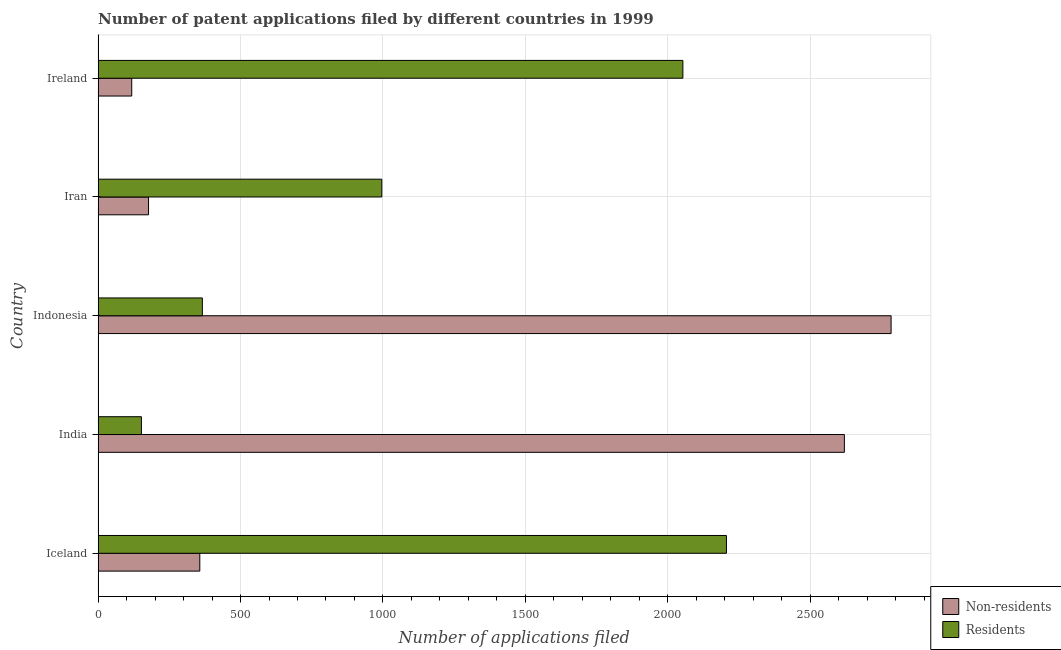How many different coloured bars are there?
Give a very brief answer. 2. Are the number of bars per tick equal to the number of legend labels?
Provide a short and direct response. Yes. Are the number of bars on each tick of the Y-axis equal?
Provide a succinct answer. Yes. How many bars are there on the 1st tick from the top?
Provide a succinct answer. 2. How many bars are there on the 2nd tick from the bottom?
Provide a short and direct response. 2. What is the number of patent applications by non residents in Indonesia?
Provide a short and direct response. 2784. Across all countries, what is the maximum number of patent applications by non residents?
Provide a short and direct response. 2784. Across all countries, what is the minimum number of patent applications by residents?
Your response must be concise. 152. In which country was the number of patent applications by non residents minimum?
Your answer should be compact. Ireland. What is the total number of patent applications by non residents in the graph?
Provide a short and direct response. 6056. What is the difference between the number of patent applications by residents in India and that in Iran?
Provide a succinct answer. -844. What is the difference between the number of patent applications by non residents in Iran and the number of patent applications by residents in India?
Your answer should be compact. 25. What is the average number of patent applications by residents per country?
Offer a very short reply. 1154.6. What is the difference between the number of patent applications by residents and number of patent applications by non residents in Indonesia?
Make the answer very short. -2418. In how many countries, is the number of patent applications by residents greater than 2700 ?
Offer a terse response. 0. What is the ratio of the number of patent applications by residents in Iceland to that in India?
Give a very brief answer. 14.51. Is the difference between the number of patent applications by non residents in India and Indonesia greater than the difference between the number of patent applications by residents in India and Indonesia?
Provide a short and direct response. Yes. What is the difference between the highest and the second highest number of patent applications by non residents?
Your answer should be very brief. 164. What is the difference between the highest and the lowest number of patent applications by non residents?
Provide a succinct answer. 2666. In how many countries, is the number of patent applications by non residents greater than the average number of patent applications by non residents taken over all countries?
Keep it short and to the point. 2. Is the sum of the number of patent applications by residents in Indonesia and Ireland greater than the maximum number of patent applications by non residents across all countries?
Your answer should be compact. No. What does the 2nd bar from the top in India represents?
Your answer should be very brief. Non-residents. What does the 2nd bar from the bottom in Iran represents?
Give a very brief answer. Residents. How many bars are there?
Provide a succinct answer. 10. Are all the bars in the graph horizontal?
Give a very brief answer. Yes. Are the values on the major ticks of X-axis written in scientific E-notation?
Keep it short and to the point. No. Does the graph contain any zero values?
Make the answer very short. No. Where does the legend appear in the graph?
Offer a terse response. Bottom right. How many legend labels are there?
Give a very brief answer. 2. How are the legend labels stacked?
Provide a short and direct response. Vertical. What is the title of the graph?
Give a very brief answer. Number of patent applications filed by different countries in 1999. Does "Commercial service exports" appear as one of the legend labels in the graph?
Offer a terse response. No. What is the label or title of the X-axis?
Your response must be concise. Number of applications filed. What is the label or title of the Y-axis?
Ensure brevity in your answer.  Country. What is the Number of applications filed of Non-residents in Iceland?
Your answer should be very brief. 357. What is the Number of applications filed of Residents in Iceland?
Ensure brevity in your answer.  2206. What is the Number of applications filed in Non-residents in India?
Offer a very short reply. 2620. What is the Number of applications filed in Residents in India?
Give a very brief answer. 152. What is the Number of applications filed of Non-residents in Indonesia?
Ensure brevity in your answer.  2784. What is the Number of applications filed of Residents in Indonesia?
Provide a succinct answer. 366. What is the Number of applications filed of Non-residents in Iran?
Make the answer very short. 177. What is the Number of applications filed of Residents in Iran?
Your response must be concise. 996. What is the Number of applications filed in Non-residents in Ireland?
Your answer should be very brief. 118. What is the Number of applications filed of Residents in Ireland?
Your response must be concise. 2053. Across all countries, what is the maximum Number of applications filed in Non-residents?
Ensure brevity in your answer.  2784. Across all countries, what is the maximum Number of applications filed in Residents?
Provide a succinct answer. 2206. Across all countries, what is the minimum Number of applications filed in Non-residents?
Your answer should be compact. 118. Across all countries, what is the minimum Number of applications filed in Residents?
Provide a short and direct response. 152. What is the total Number of applications filed in Non-residents in the graph?
Offer a terse response. 6056. What is the total Number of applications filed in Residents in the graph?
Provide a succinct answer. 5773. What is the difference between the Number of applications filed in Non-residents in Iceland and that in India?
Give a very brief answer. -2263. What is the difference between the Number of applications filed of Residents in Iceland and that in India?
Offer a very short reply. 2054. What is the difference between the Number of applications filed in Non-residents in Iceland and that in Indonesia?
Keep it short and to the point. -2427. What is the difference between the Number of applications filed in Residents in Iceland and that in Indonesia?
Offer a very short reply. 1840. What is the difference between the Number of applications filed in Non-residents in Iceland and that in Iran?
Offer a terse response. 180. What is the difference between the Number of applications filed in Residents in Iceland and that in Iran?
Your response must be concise. 1210. What is the difference between the Number of applications filed in Non-residents in Iceland and that in Ireland?
Provide a succinct answer. 239. What is the difference between the Number of applications filed in Residents in Iceland and that in Ireland?
Give a very brief answer. 153. What is the difference between the Number of applications filed in Non-residents in India and that in Indonesia?
Offer a very short reply. -164. What is the difference between the Number of applications filed of Residents in India and that in Indonesia?
Your answer should be compact. -214. What is the difference between the Number of applications filed of Non-residents in India and that in Iran?
Make the answer very short. 2443. What is the difference between the Number of applications filed in Residents in India and that in Iran?
Ensure brevity in your answer.  -844. What is the difference between the Number of applications filed in Non-residents in India and that in Ireland?
Ensure brevity in your answer.  2502. What is the difference between the Number of applications filed of Residents in India and that in Ireland?
Offer a terse response. -1901. What is the difference between the Number of applications filed in Non-residents in Indonesia and that in Iran?
Offer a terse response. 2607. What is the difference between the Number of applications filed in Residents in Indonesia and that in Iran?
Ensure brevity in your answer.  -630. What is the difference between the Number of applications filed in Non-residents in Indonesia and that in Ireland?
Give a very brief answer. 2666. What is the difference between the Number of applications filed of Residents in Indonesia and that in Ireland?
Your answer should be very brief. -1687. What is the difference between the Number of applications filed in Non-residents in Iran and that in Ireland?
Provide a short and direct response. 59. What is the difference between the Number of applications filed in Residents in Iran and that in Ireland?
Offer a very short reply. -1057. What is the difference between the Number of applications filed in Non-residents in Iceland and the Number of applications filed in Residents in India?
Your answer should be very brief. 205. What is the difference between the Number of applications filed of Non-residents in Iceland and the Number of applications filed of Residents in Iran?
Ensure brevity in your answer.  -639. What is the difference between the Number of applications filed in Non-residents in Iceland and the Number of applications filed in Residents in Ireland?
Make the answer very short. -1696. What is the difference between the Number of applications filed in Non-residents in India and the Number of applications filed in Residents in Indonesia?
Provide a succinct answer. 2254. What is the difference between the Number of applications filed of Non-residents in India and the Number of applications filed of Residents in Iran?
Provide a short and direct response. 1624. What is the difference between the Number of applications filed in Non-residents in India and the Number of applications filed in Residents in Ireland?
Provide a succinct answer. 567. What is the difference between the Number of applications filed of Non-residents in Indonesia and the Number of applications filed of Residents in Iran?
Ensure brevity in your answer.  1788. What is the difference between the Number of applications filed of Non-residents in Indonesia and the Number of applications filed of Residents in Ireland?
Your answer should be compact. 731. What is the difference between the Number of applications filed of Non-residents in Iran and the Number of applications filed of Residents in Ireland?
Offer a terse response. -1876. What is the average Number of applications filed of Non-residents per country?
Your answer should be very brief. 1211.2. What is the average Number of applications filed of Residents per country?
Give a very brief answer. 1154.6. What is the difference between the Number of applications filed in Non-residents and Number of applications filed in Residents in Iceland?
Offer a terse response. -1849. What is the difference between the Number of applications filed in Non-residents and Number of applications filed in Residents in India?
Give a very brief answer. 2468. What is the difference between the Number of applications filed in Non-residents and Number of applications filed in Residents in Indonesia?
Offer a terse response. 2418. What is the difference between the Number of applications filed of Non-residents and Number of applications filed of Residents in Iran?
Your response must be concise. -819. What is the difference between the Number of applications filed of Non-residents and Number of applications filed of Residents in Ireland?
Offer a terse response. -1935. What is the ratio of the Number of applications filed of Non-residents in Iceland to that in India?
Provide a succinct answer. 0.14. What is the ratio of the Number of applications filed in Residents in Iceland to that in India?
Give a very brief answer. 14.51. What is the ratio of the Number of applications filed in Non-residents in Iceland to that in Indonesia?
Provide a succinct answer. 0.13. What is the ratio of the Number of applications filed of Residents in Iceland to that in Indonesia?
Ensure brevity in your answer.  6.03. What is the ratio of the Number of applications filed in Non-residents in Iceland to that in Iran?
Your response must be concise. 2.02. What is the ratio of the Number of applications filed of Residents in Iceland to that in Iran?
Your answer should be compact. 2.21. What is the ratio of the Number of applications filed in Non-residents in Iceland to that in Ireland?
Offer a very short reply. 3.03. What is the ratio of the Number of applications filed of Residents in Iceland to that in Ireland?
Make the answer very short. 1.07. What is the ratio of the Number of applications filed of Non-residents in India to that in Indonesia?
Your answer should be compact. 0.94. What is the ratio of the Number of applications filed of Residents in India to that in Indonesia?
Your response must be concise. 0.42. What is the ratio of the Number of applications filed of Non-residents in India to that in Iran?
Offer a very short reply. 14.8. What is the ratio of the Number of applications filed in Residents in India to that in Iran?
Your answer should be compact. 0.15. What is the ratio of the Number of applications filed of Non-residents in India to that in Ireland?
Give a very brief answer. 22.2. What is the ratio of the Number of applications filed of Residents in India to that in Ireland?
Your response must be concise. 0.07. What is the ratio of the Number of applications filed of Non-residents in Indonesia to that in Iran?
Your response must be concise. 15.73. What is the ratio of the Number of applications filed of Residents in Indonesia to that in Iran?
Your answer should be compact. 0.37. What is the ratio of the Number of applications filed in Non-residents in Indonesia to that in Ireland?
Provide a succinct answer. 23.59. What is the ratio of the Number of applications filed of Residents in Indonesia to that in Ireland?
Provide a short and direct response. 0.18. What is the ratio of the Number of applications filed in Residents in Iran to that in Ireland?
Offer a terse response. 0.49. What is the difference between the highest and the second highest Number of applications filed in Non-residents?
Offer a very short reply. 164. What is the difference between the highest and the second highest Number of applications filed in Residents?
Make the answer very short. 153. What is the difference between the highest and the lowest Number of applications filed of Non-residents?
Offer a terse response. 2666. What is the difference between the highest and the lowest Number of applications filed in Residents?
Your answer should be very brief. 2054. 